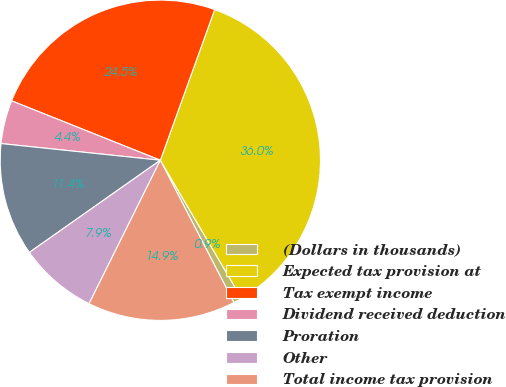<chart> <loc_0><loc_0><loc_500><loc_500><pie_chart><fcel>(Dollars in thousands)<fcel>Expected tax provision at<fcel>Tax exempt income<fcel>Dividend received deduction<fcel>Proration<fcel>Other<fcel>Total income tax provision<nl><fcel>0.87%<fcel>36.03%<fcel>24.46%<fcel>4.39%<fcel>11.42%<fcel>7.9%<fcel>14.93%<nl></chart> 